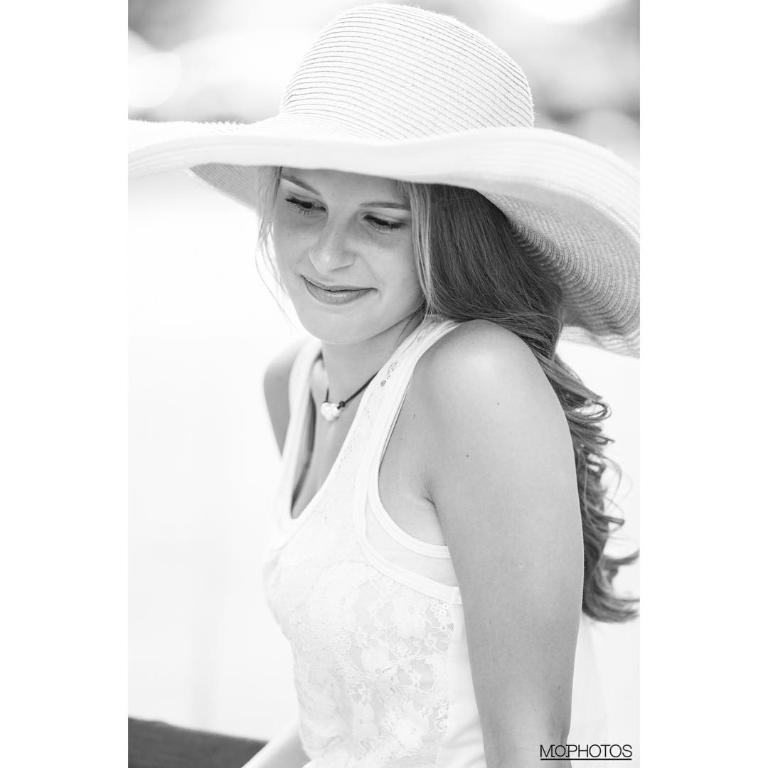What can be seen in the image? There is a person in the image. Can you describe the person's attire? The person is wearing a dress and a hat. What is the color scheme of the image? The image is black and white. How would you describe the background of the image? The background of the image is blurred. How does the person in the image contribute to reducing pollution? There is no information in the image about the person's actions or their impact on pollution. 